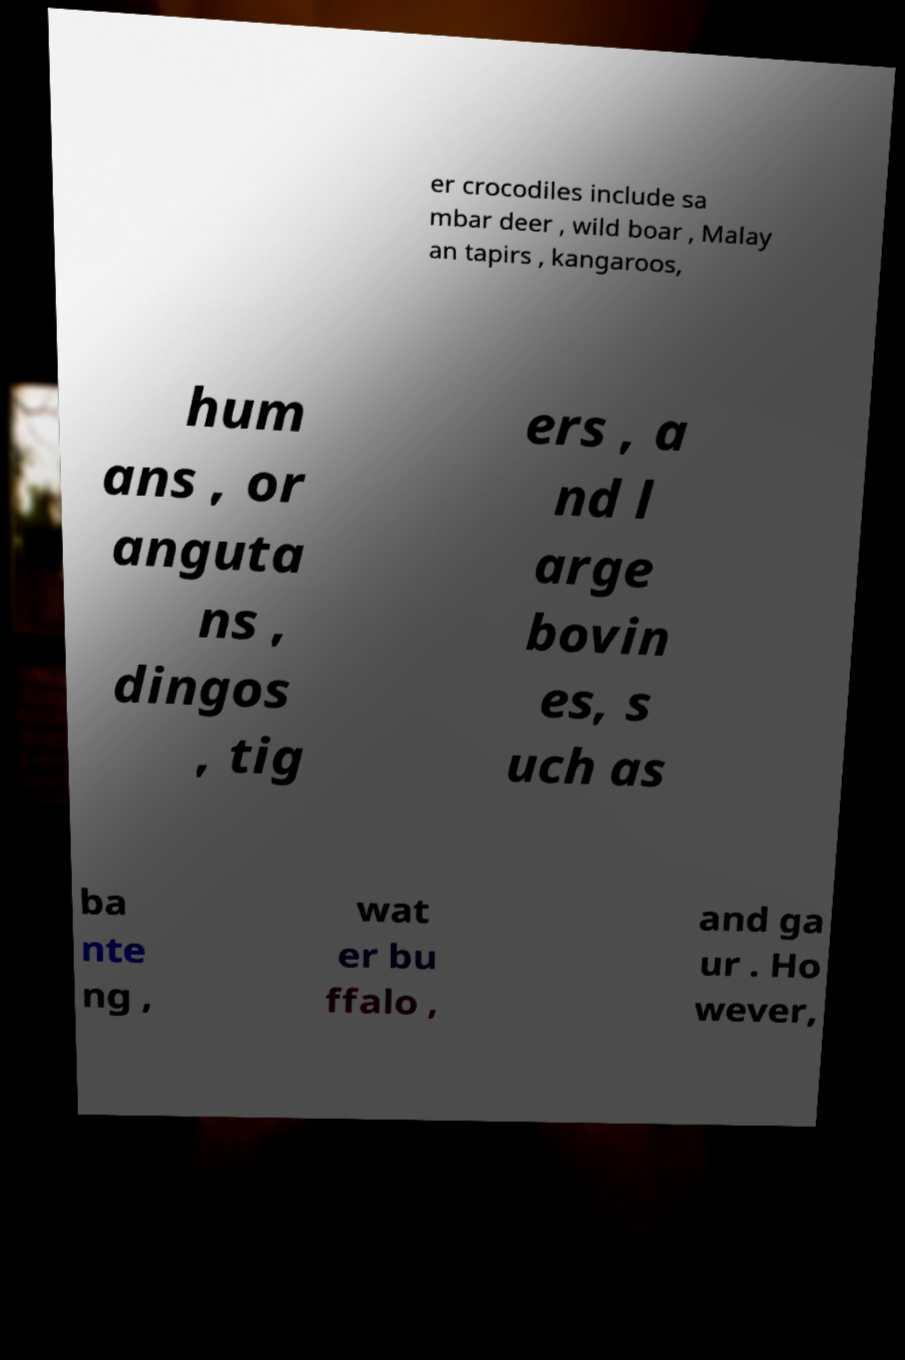Could you assist in decoding the text presented in this image and type it out clearly? er crocodiles include sa mbar deer , wild boar , Malay an tapirs , kangaroos, hum ans , or anguta ns , dingos , tig ers , a nd l arge bovin es, s uch as ba nte ng , wat er bu ffalo , and ga ur . Ho wever, 